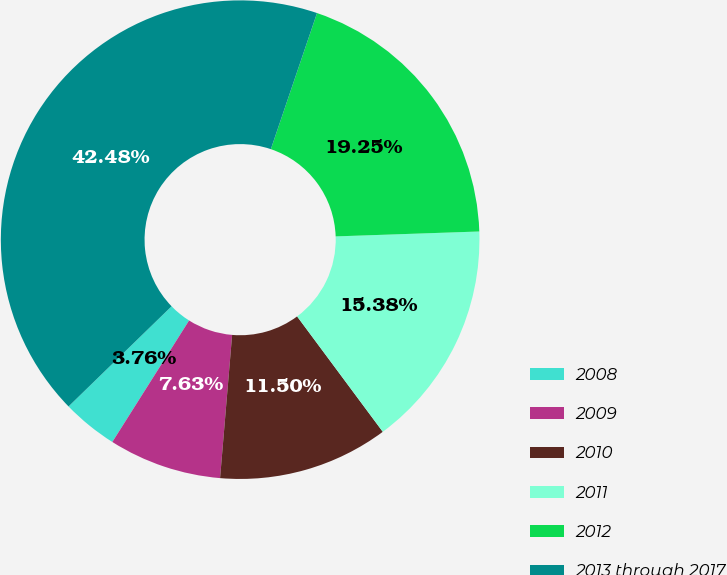<chart> <loc_0><loc_0><loc_500><loc_500><pie_chart><fcel>2008<fcel>2009<fcel>2010<fcel>2011<fcel>2012<fcel>2013 through 2017<nl><fcel>3.76%<fcel>7.63%<fcel>11.5%<fcel>15.38%<fcel>19.25%<fcel>42.48%<nl></chart> 